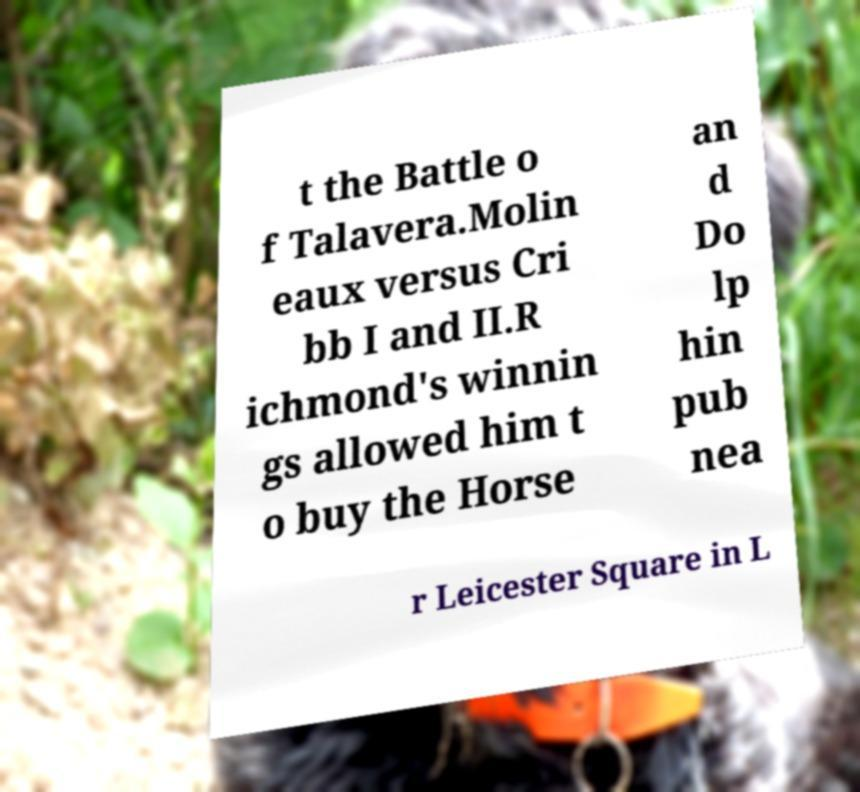Please read and relay the text visible in this image. What does it say? t the Battle o f Talavera.Molin eaux versus Cri bb I and II.R ichmond's winnin gs allowed him t o buy the Horse an d Do lp hin pub nea r Leicester Square in L 